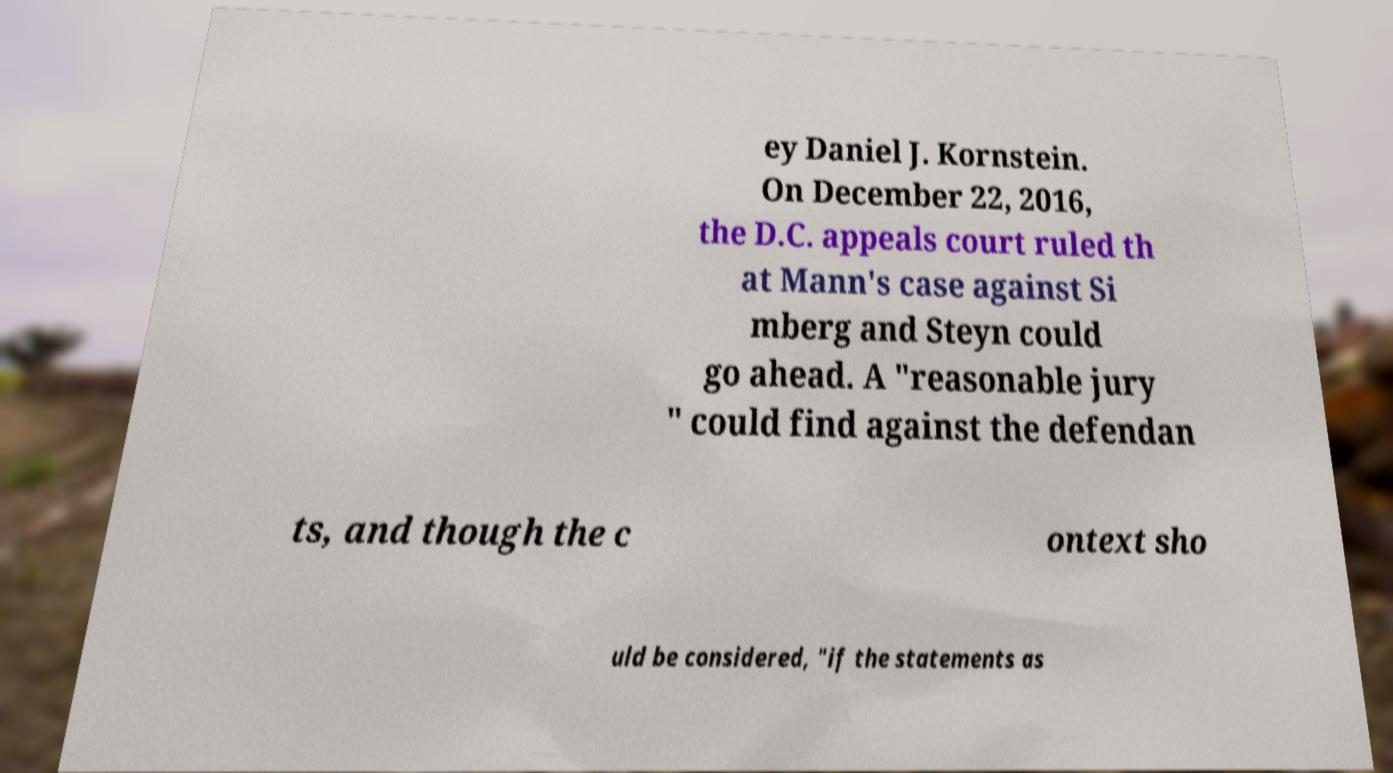Can you read and provide the text displayed in the image?This photo seems to have some interesting text. Can you extract and type it out for me? ey Daniel J. Kornstein. On December 22, 2016, the D.C. appeals court ruled th at Mann's case against Si mberg and Steyn could go ahead. A "reasonable jury " could find against the defendan ts, and though the c ontext sho uld be considered, "if the statements as 